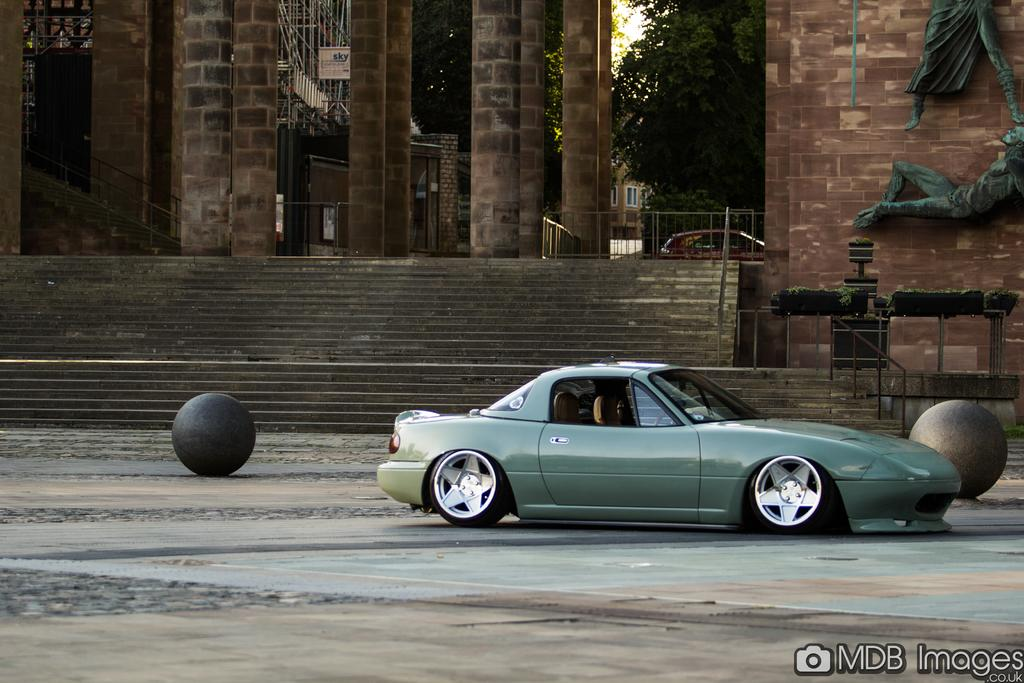What types of objects can be seen in the image? There are vehicles, steps, walls, boards, a tree, windows, a railing, and statues on the wall in the image. Can you describe the architectural features in the image? The image features steps, walls, windows, and a railing. What type of vegetation is present in the image? There is a tree and plants in the image. Are there any decorative elements in the image? Yes, there are statues on the wall in the image. What type of straw is being used to create the flame in the image? There is no straw or flame present in the image. What channel is being used to broadcast the image? The question about the channel is not relevant to the image itself, as it refers to the medium through which the image is being viewed. 